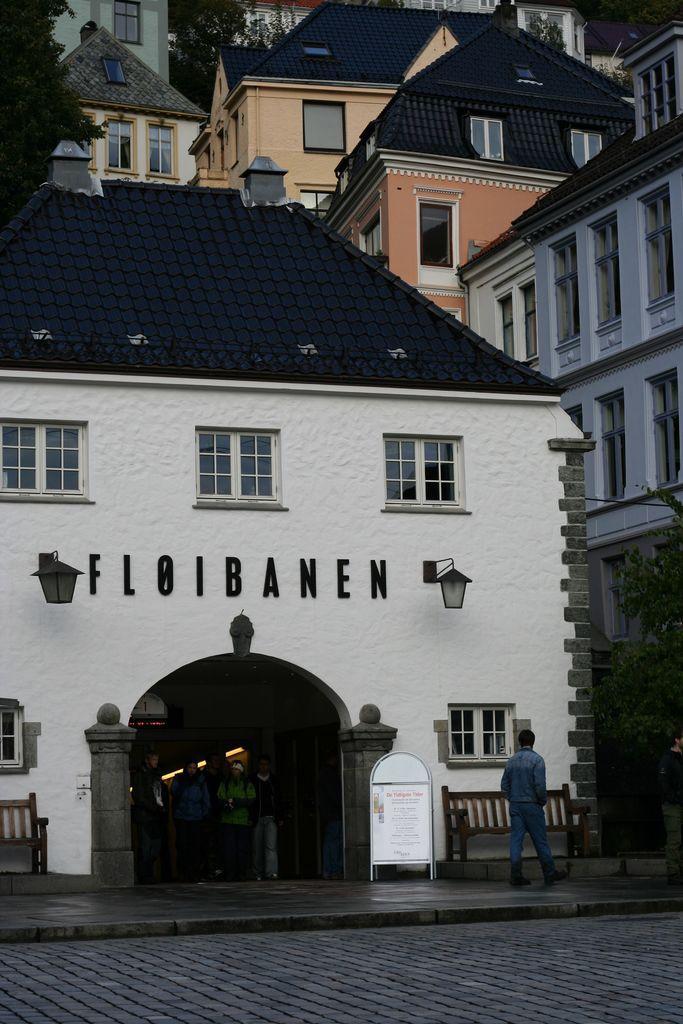How would you summarize this image in a sentence or two? This picture is clicked outside. In the foreground we can see the pavement and a person walking on the ground and we can see a bench and the text on the board. In the center we can see the group of persons, lights, text on the house, wall mounted lamps and a tree. In the background we can see the houses, trees and some other objects. 